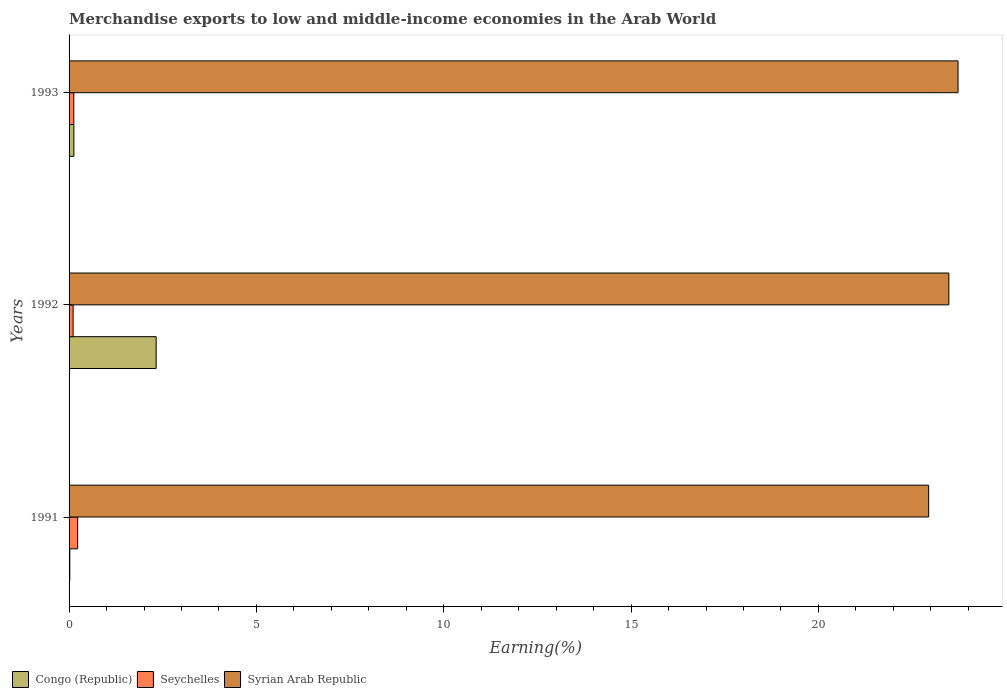How many different coloured bars are there?
Provide a succinct answer. 3. How many groups of bars are there?
Your response must be concise. 3. How many bars are there on the 3rd tick from the top?
Provide a succinct answer. 3. How many bars are there on the 3rd tick from the bottom?
Provide a succinct answer. 3. What is the label of the 3rd group of bars from the top?
Provide a succinct answer. 1991. In how many cases, is the number of bars for a given year not equal to the number of legend labels?
Provide a succinct answer. 0. What is the percentage of amount earned from merchandise exports in Seychelles in 1991?
Give a very brief answer. 0.23. Across all years, what is the maximum percentage of amount earned from merchandise exports in Seychelles?
Your answer should be very brief. 0.23. Across all years, what is the minimum percentage of amount earned from merchandise exports in Congo (Republic)?
Your response must be concise. 0.02. In which year was the percentage of amount earned from merchandise exports in Syrian Arab Republic maximum?
Ensure brevity in your answer.  1993. In which year was the percentage of amount earned from merchandise exports in Congo (Republic) minimum?
Ensure brevity in your answer.  1991. What is the total percentage of amount earned from merchandise exports in Syrian Arab Republic in the graph?
Your response must be concise. 70.15. What is the difference between the percentage of amount earned from merchandise exports in Seychelles in 1992 and that in 1993?
Provide a succinct answer. -0.02. What is the difference between the percentage of amount earned from merchandise exports in Congo (Republic) in 1992 and the percentage of amount earned from merchandise exports in Syrian Arab Republic in 1993?
Your response must be concise. -21.4. What is the average percentage of amount earned from merchandise exports in Syrian Arab Republic per year?
Provide a short and direct response. 23.38. In the year 1993, what is the difference between the percentage of amount earned from merchandise exports in Congo (Republic) and percentage of amount earned from merchandise exports in Syrian Arab Republic?
Your response must be concise. -23.6. In how many years, is the percentage of amount earned from merchandise exports in Syrian Arab Republic greater than 8 %?
Your response must be concise. 3. What is the ratio of the percentage of amount earned from merchandise exports in Congo (Republic) in 1992 to that in 1993?
Offer a terse response. 18.08. Is the percentage of amount earned from merchandise exports in Syrian Arab Republic in 1991 less than that in 1993?
Your answer should be compact. Yes. Is the difference between the percentage of amount earned from merchandise exports in Congo (Republic) in 1991 and 1993 greater than the difference between the percentage of amount earned from merchandise exports in Syrian Arab Republic in 1991 and 1993?
Provide a short and direct response. Yes. What is the difference between the highest and the second highest percentage of amount earned from merchandise exports in Syrian Arab Republic?
Provide a succinct answer. 0.25. What is the difference between the highest and the lowest percentage of amount earned from merchandise exports in Congo (Republic)?
Offer a terse response. 2.31. In how many years, is the percentage of amount earned from merchandise exports in Syrian Arab Republic greater than the average percentage of amount earned from merchandise exports in Syrian Arab Republic taken over all years?
Provide a short and direct response. 2. Is the sum of the percentage of amount earned from merchandise exports in Congo (Republic) in 1992 and 1993 greater than the maximum percentage of amount earned from merchandise exports in Syrian Arab Republic across all years?
Offer a terse response. No. What does the 3rd bar from the top in 1993 represents?
Offer a very short reply. Congo (Republic). What does the 1st bar from the bottom in 1992 represents?
Give a very brief answer. Congo (Republic). How many bars are there?
Your answer should be compact. 9. Are the values on the major ticks of X-axis written in scientific E-notation?
Keep it short and to the point. No. Does the graph contain grids?
Your response must be concise. No. How many legend labels are there?
Make the answer very short. 3. How are the legend labels stacked?
Offer a very short reply. Horizontal. What is the title of the graph?
Give a very brief answer. Merchandise exports to low and middle-income economies in the Arab World. Does "Djibouti" appear as one of the legend labels in the graph?
Provide a succinct answer. No. What is the label or title of the X-axis?
Keep it short and to the point. Earning(%). What is the label or title of the Y-axis?
Offer a very short reply. Years. What is the Earning(%) of Congo (Republic) in 1991?
Offer a terse response. 0.02. What is the Earning(%) of Seychelles in 1991?
Make the answer very short. 0.23. What is the Earning(%) in Syrian Arab Republic in 1991?
Provide a succinct answer. 22.94. What is the Earning(%) in Congo (Republic) in 1992?
Your answer should be compact. 2.32. What is the Earning(%) in Seychelles in 1992?
Your response must be concise. 0.11. What is the Earning(%) in Syrian Arab Republic in 1992?
Give a very brief answer. 23.48. What is the Earning(%) in Congo (Republic) in 1993?
Your response must be concise. 0.13. What is the Earning(%) of Seychelles in 1993?
Offer a terse response. 0.13. What is the Earning(%) of Syrian Arab Republic in 1993?
Ensure brevity in your answer.  23.73. Across all years, what is the maximum Earning(%) in Congo (Republic)?
Offer a very short reply. 2.32. Across all years, what is the maximum Earning(%) in Seychelles?
Provide a succinct answer. 0.23. Across all years, what is the maximum Earning(%) in Syrian Arab Republic?
Make the answer very short. 23.73. Across all years, what is the minimum Earning(%) of Congo (Republic)?
Give a very brief answer. 0.02. Across all years, what is the minimum Earning(%) of Seychelles?
Provide a short and direct response. 0.11. Across all years, what is the minimum Earning(%) of Syrian Arab Republic?
Provide a short and direct response. 22.94. What is the total Earning(%) in Congo (Republic) in the graph?
Provide a succinct answer. 2.47. What is the total Earning(%) of Seychelles in the graph?
Your answer should be very brief. 0.46. What is the total Earning(%) of Syrian Arab Republic in the graph?
Your answer should be very brief. 70.15. What is the difference between the Earning(%) in Congo (Republic) in 1991 and that in 1992?
Provide a succinct answer. -2.31. What is the difference between the Earning(%) in Seychelles in 1991 and that in 1992?
Offer a terse response. 0.12. What is the difference between the Earning(%) of Syrian Arab Republic in 1991 and that in 1992?
Offer a very short reply. -0.54. What is the difference between the Earning(%) in Congo (Republic) in 1991 and that in 1993?
Offer a very short reply. -0.11. What is the difference between the Earning(%) in Seychelles in 1991 and that in 1993?
Provide a short and direct response. 0.1. What is the difference between the Earning(%) in Syrian Arab Republic in 1991 and that in 1993?
Your answer should be compact. -0.78. What is the difference between the Earning(%) of Congo (Republic) in 1992 and that in 1993?
Your answer should be compact. 2.2. What is the difference between the Earning(%) in Seychelles in 1992 and that in 1993?
Your answer should be very brief. -0.02. What is the difference between the Earning(%) of Syrian Arab Republic in 1992 and that in 1993?
Make the answer very short. -0.24. What is the difference between the Earning(%) of Congo (Republic) in 1991 and the Earning(%) of Seychelles in 1992?
Keep it short and to the point. -0.09. What is the difference between the Earning(%) in Congo (Republic) in 1991 and the Earning(%) in Syrian Arab Republic in 1992?
Your response must be concise. -23.46. What is the difference between the Earning(%) in Seychelles in 1991 and the Earning(%) in Syrian Arab Republic in 1992?
Give a very brief answer. -23.25. What is the difference between the Earning(%) in Congo (Republic) in 1991 and the Earning(%) in Seychelles in 1993?
Your answer should be compact. -0.11. What is the difference between the Earning(%) in Congo (Republic) in 1991 and the Earning(%) in Syrian Arab Republic in 1993?
Ensure brevity in your answer.  -23.71. What is the difference between the Earning(%) of Seychelles in 1991 and the Earning(%) of Syrian Arab Republic in 1993?
Give a very brief answer. -23.5. What is the difference between the Earning(%) in Congo (Republic) in 1992 and the Earning(%) in Seychelles in 1993?
Keep it short and to the point. 2.2. What is the difference between the Earning(%) in Congo (Republic) in 1992 and the Earning(%) in Syrian Arab Republic in 1993?
Offer a terse response. -21.4. What is the difference between the Earning(%) of Seychelles in 1992 and the Earning(%) of Syrian Arab Republic in 1993?
Make the answer very short. -23.62. What is the average Earning(%) in Congo (Republic) per year?
Ensure brevity in your answer.  0.82. What is the average Earning(%) in Seychelles per year?
Make the answer very short. 0.15. What is the average Earning(%) of Syrian Arab Republic per year?
Keep it short and to the point. 23.38. In the year 1991, what is the difference between the Earning(%) in Congo (Republic) and Earning(%) in Seychelles?
Your response must be concise. -0.21. In the year 1991, what is the difference between the Earning(%) of Congo (Republic) and Earning(%) of Syrian Arab Republic?
Offer a terse response. -22.92. In the year 1991, what is the difference between the Earning(%) in Seychelles and Earning(%) in Syrian Arab Republic?
Keep it short and to the point. -22.71. In the year 1992, what is the difference between the Earning(%) of Congo (Republic) and Earning(%) of Seychelles?
Your answer should be compact. 2.22. In the year 1992, what is the difference between the Earning(%) of Congo (Republic) and Earning(%) of Syrian Arab Republic?
Your answer should be compact. -21.16. In the year 1992, what is the difference between the Earning(%) in Seychelles and Earning(%) in Syrian Arab Republic?
Keep it short and to the point. -23.37. In the year 1993, what is the difference between the Earning(%) of Congo (Republic) and Earning(%) of Seychelles?
Your response must be concise. 0. In the year 1993, what is the difference between the Earning(%) in Congo (Republic) and Earning(%) in Syrian Arab Republic?
Offer a very short reply. -23.6. In the year 1993, what is the difference between the Earning(%) of Seychelles and Earning(%) of Syrian Arab Republic?
Give a very brief answer. -23.6. What is the ratio of the Earning(%) in Congo (Republic) in 1991 to that in 1992?
Your answer should be very brief. 0.01. What is the ratio of the Earning(%) in Seychelles in 1991 to that in 1992?
Offer a very short reply. 2.13. What is the ratio of the Earning(%) in Congo (Republic) in 1991 to that in 1993?
Provide a succinct answer. 0.15. What is the ratio of the Earning(%) in Seychelles in 1991 to that in 1993?
Provide a short and direct response. 1.82. What is the ratio of the Earning(%) of Congo (Republic) in 1992 to that in 1993?
Your answer should be very brief. 18.08. What is the ratio of the Earning(%) of Seychelles in 1992 to that in 1993?
Provide a succinct answer. 0.85. What is the ratio of the Earning(%) in Syrian Arab Republic in 1992 to that in 1993?
Your answer should be very brief. 0.99. What is the difference between the highest and the second highest Earning(%) in Congo (Republic)?
Provide a short and direct response. 2.2. What is the difference between the highest and the second highest Earning(%) in Seychelles?
Give a very brief answer. 0.1. What is the difference between the highest and the second highest Earning(%) of Syrian Arab Republic?
Your answer should be compact. 0.24. What is the difference between the highest and the lowest Earning(%) in Congo (Republic)?
Provide a short and direct response. 2.31. What is the difference between the highest and the lowest Earning(%) in Seychelles?
Ensure brevity in your answer.  0.12. What is the difference between the highest and the lowest Earning(%) in Syrian Arab Republic?
Offer a very short reply. 0.78. 